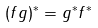Convert formula to latex. <formula><loc_0><loc_0><loc_500><loc_500>( f g ) ^ { * } = g ^ { * } f ^ { * }</formula> 